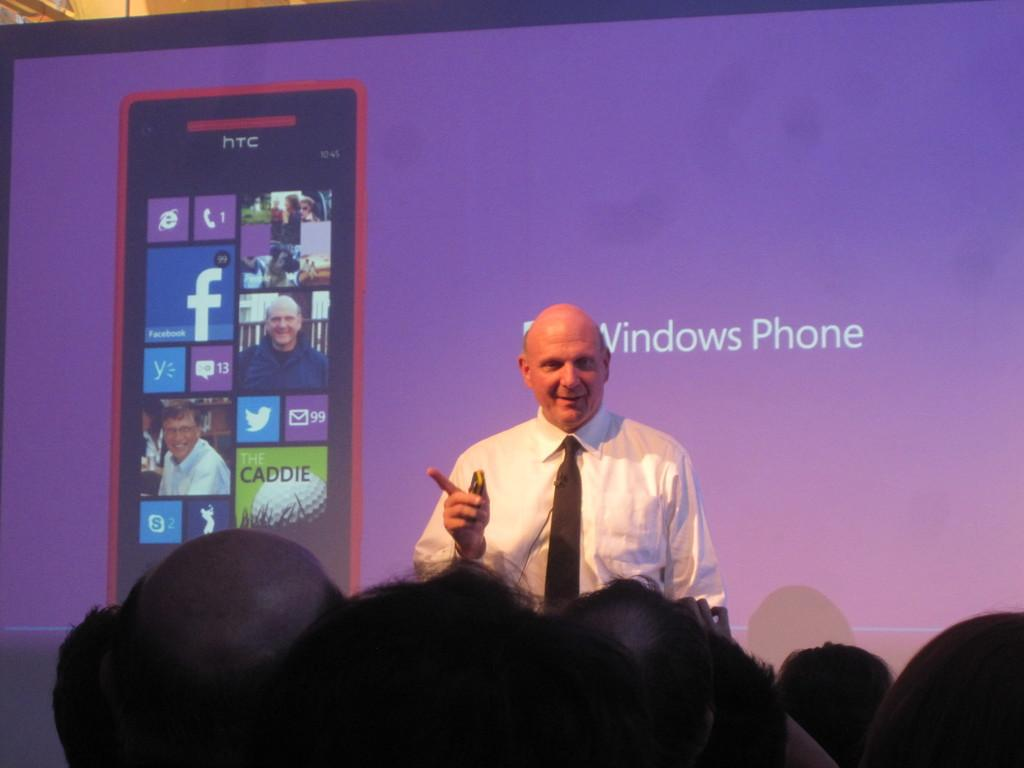<image>
Present a compact description of the photo's key features. A man stands in front of a large screen with a phone in it and the words Windows phone. 